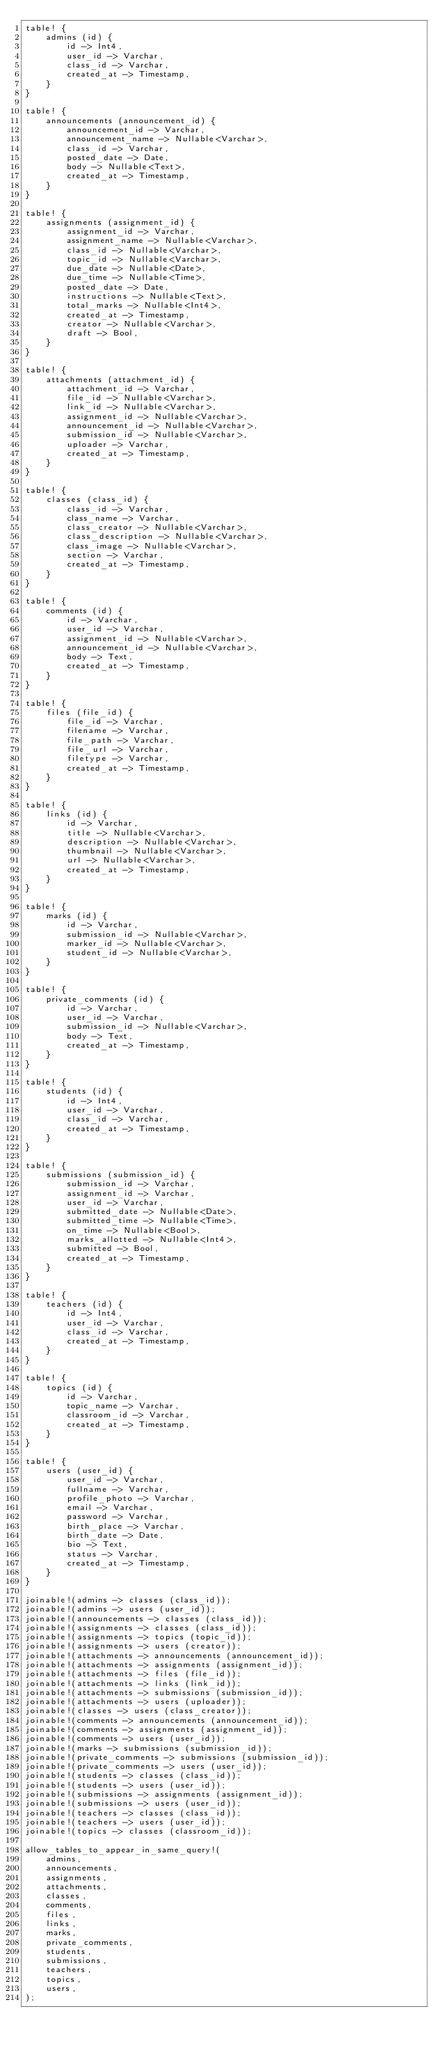Convert code to text. <code><loc_0><loc_0><loc_500><loc_500><_Rust_>table! {
    admins (id) {
        id -> Int4,
        user_id -> Varchar,
        class_id -> Varchar,
        created_at -> Timestamp,
    }
}

table! {
    announcements (announcement_id) {
        announcement_id -> Varchar,
        announcement_name -> Nullable<Varchar>,
        class_id -> Varchar,
        posted_date -> Date,
        body -> Nullable<Text>,
        created_at -> Timestamp,
    }
}

table! {
    assignments (assignment_id) {
        assignment_id -> Varchar,
        assignment_name -> Nullable<Varchar>,
        class_id -> Nullable<Varchar>,
        topic_id -> Nullable<Varchar>,
        due_date -> Nullable<Date>,
        due_time -> Nullable<Time>,
        posted_date -> Date,
        instructions -> Nullable<Text>,
        total_marks -> Nullable<Int4>,
        created_at -> Timestamp,
        creator -> Nullable<Varchar>,
        draft -> Bool,
    }
}

table! {
    attachments (attachment_id) {
        attachment_id -> Varchar,
        file_id -> Nullable<Varchar>,
        link_id -> Nullable<Varchar>,
        assignment_id -> Nullable<Varchar>,
        announcement_id -> Nullable<Varchar>,
        submission_id -> Nullable<Varchar>,
        uploader -> Varchar,
        created_at -> Timestamp,
    }
}

table! {
    classes (class_id) {
        class_id -> Varchar,
        class_name -> Varchar,
        class_creator -> Nullable<Varchar>,
        class_description -> Nullable<Varchar>,
        class_image -> Nullable<Varchar>,
        section -> Varchar,
        created_at -> Timestamp,
    }
}

table! {
    comments (id) {
        id -> Varchar,
        user_id -> Varchar,
        assignment_id -> Nullable<Varchar>,
        announcement_id -> Nullable<Varchar>,
        body -> Text,
        created_at -> Timestamp,
    }
}

table! {
    files (file_id) {
        file_id -> Varchar,
        filename -> Varchar,
        file_path -> Varchar,
        file_url -> Varchar,
        filetype -> Varchar,
        created_at -> Timestamp,
    }
}

table! {
    links (id) {
        id -> Varchar,
        title -> Nullable<Varchar>,
        description -> Nullable<Varchar>,
        thumbnail -> Nullable<Varchar>,
        url -> Nullable<Varchar>,
        created_at -> Timestamp,
    }
}

table! {
    marks (id) {
        id -> Varchar,
        submission_id -> Nullable<Varchar>,
        marker_id -> Nullable<Varchar>,
        student_id -> Nullable<Varchar>,
    }
}

table! {
    private_comments (id) {
        id -> Varchar,
        user_id -> Varchar,
        submission_id -> Nullable<Varchar>,
        body -> Text,
        created_at -> Timestamp,
    }
}

table! {
    students (id) {
        id -> Int4,
        user_id -> Varchar,
        class_id -> Varchar,
        created_at -> Timestamp,
    }
}

table! {
    submissions (submission_id) {
        submission_id -> Varchar,
        assignment_id -> Varchar,
        user_id -> Varchar,
        submitted_date -> Nullable<Date>,
        submitted_time -> Nullable<Time>,
        on_time -> Nullable<Bool>,
        marks_allotted -> Nullable<Int4>,
        submitted -> Bool,
        created_at -> Timestamp,
    }
}

table! {
    teachers (id) {
        id -> Int4,
        user_id -> Varchar,
        class_id -> Varchar,
        created_at -> Timestamp,
    }
}

table! {
    topics (id) {
        id -> Varchar,
        topic_name -> Varchar,
        classroom_id -> Varchar,
        created_at -> Timestamp,
    }
}

table! {
    users (user_id) {
        user_id -> Varchar,
        fullname -> Varchar,
        profile_photo -> Varchar,
        email -> Varchar,
        password -> Varchar,
        birth_place -> Varchar,
        birth_date -> Date,
        bio -> Text,
        status -> Varchar,
        created_at -> Timestamp,
    }
}

joinable!(admins -> classes (class_id));
joinable!(admins -> users (user_id));
joinable!(announcements -> classes (class_id));
joinable!(assignments -> classes (class_id));
joinable!(assignments -> topics (topic_id));
joinable!(assignments -> users (creator));
joinable!(attachments -> announcements (announcement_id));
joinable!(attachments -> assignments (assignment_id));
joinable!(attachments -> files (file_id));
joinable!(attachments -> links (link_id));
joinable!(attachments -> submissions (submission_id));
joinable!(attachments -> users (uploader));
joinable!(classes -> users (class_creator));
joinable!(comments -> announcements (announcement_id));
joinable!(comments -> assignments (assignment_id));
joinable!(comments -> users (user_id));
joinable!(marks -> submissions (submission_id));
joinable!(private_comments -> submissions (submission_id));
joinable!(private_comments -> users (user_id));
joinable!(students -> classes (class_id));
joinable!(students -> users (user_id));
joinable!(submissions -> assignments (assignment_id));
joinable!(submissions -> users (user_id));
joinable!(teachers -> classes (class_id));
joinable!(teachers -> users (user_id));
joinable!(topics -> classes (classroom_id));

allow_tables_to_appear_in_same_query!(
    admins,
    announcements,
    assignments,
    attachments,
    classes,
    comments,
    files,
    links,
    marks,
    private_comments,
    students,
    submissions,
    teachers,
    topics,
    users,
);
</code> 